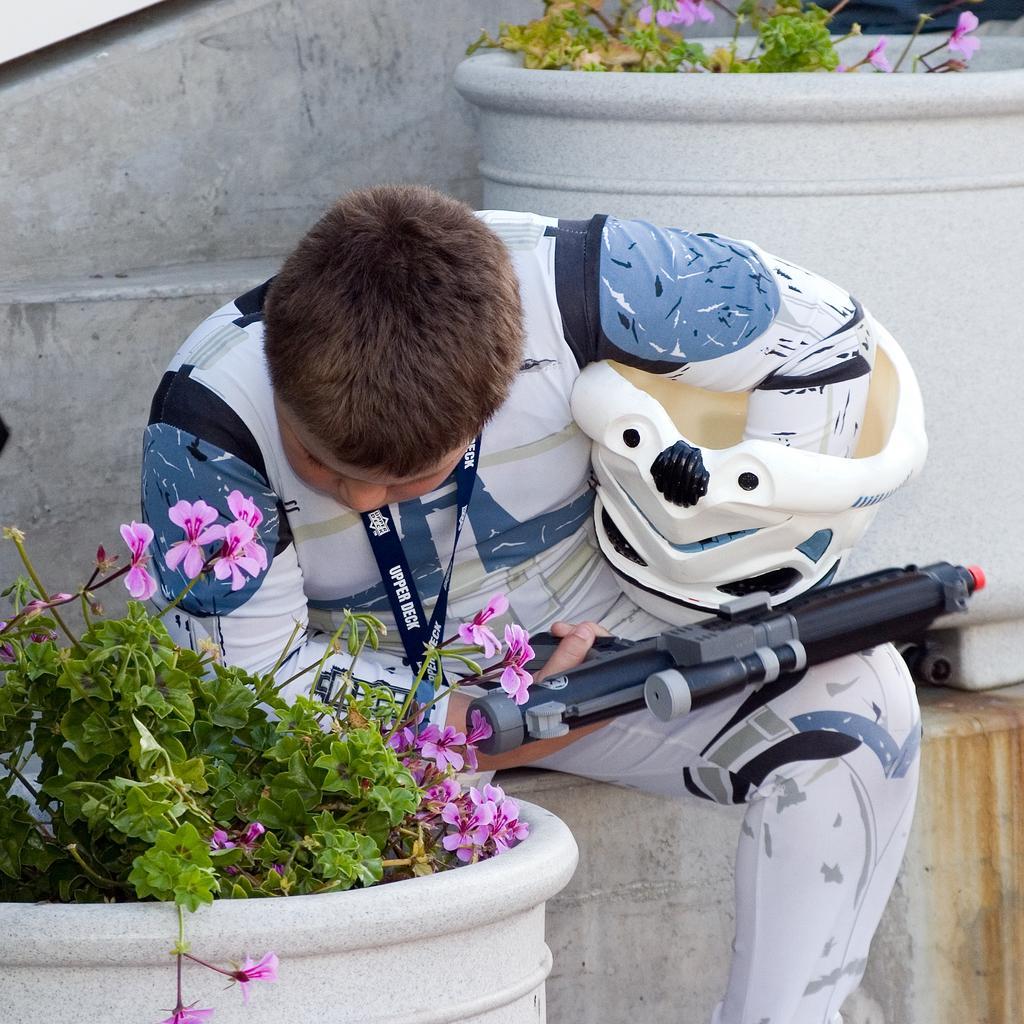Please provide a concise description of this image. In this picture I see a person holding weapon toy. I can see the plants. 